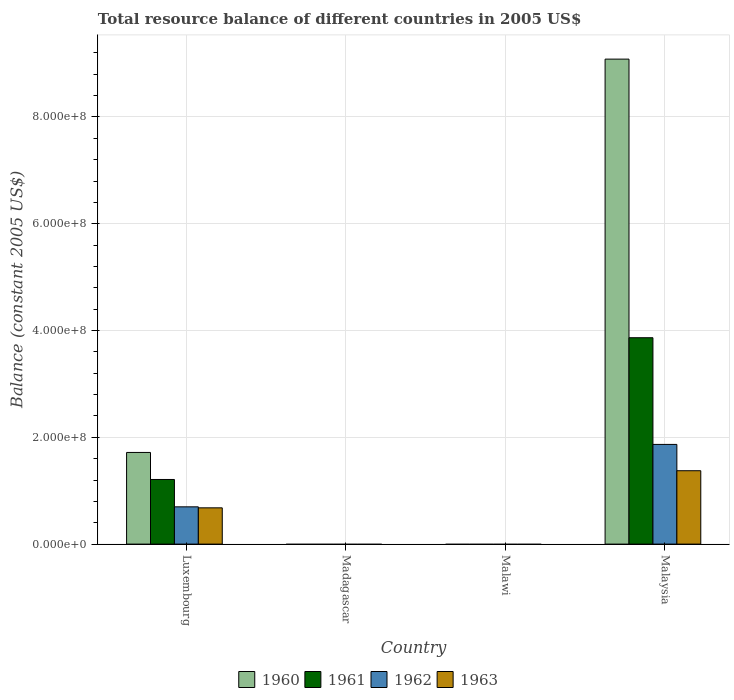Are the number of bars on each tick of the X-axis equal?
Offer a terse response. No. What is the label of the 4th group of bars from the left?
Your response must be concise. Malaysia. In how many cases, is the number of bars for a given country not equal to the number of legend labels?
Your answer should be very brief. 2. Across all countries, what is the maximum total resource balance in 1962?
Keep it short and to the point. 1.87e+08. In which country was the total resource balance in 1961 maximum?
Your answer should be very brief. Malaysia. What is the total total resource balance in 1961 in the graph?
Make the answer very short. 5.08e+08. What is the difference between the total resource balance in 1960 in Luxembourg and that in Malaysia?
Provide a succinct answer. -7.37e+08. What is the difference between the total resource balance in 1962 in Malawi and the total resource balance in 1961 in Malaysia?
Make the answer very short. -3.87e+08. What is the average total resource balance in 1962 per country?
Ensure brevity in your answer.  6.41e+07. What is the difference between the total resource balance of/in 1961 and total resource balance of/in 1962 in Malaysia?
Offer a very short reply. 2.00e+08. In how many countries, is the total resource balance in 1960 greater than 760000000 US$?
Ensure brevity in your answer.  1. What is the ratio of the total resource balance in 1960 in Luxembourg to that in Malaysia?
Give a very brief answer. 0.19. What is the difference between the highest and the lowest total resource balance in 1960?
Your answer should be very brief. 9.08e+08. Is the sum of the total resource balance in 1963 in Luxembourg and Malaysia greater than the maximum total resource balance in 1960 across all countries?
Provide a succinct answer. No. Are all the bars in the graph horizontal?
Offer a terse response. No. How many countries are there in the graph?
Your response must be concise. 4. What is the difference between two consecutive major ticks on the Y-axis?
Offer a very short reply. 2.00e+08. Are the values on the major ticks of Y-axis written in scientific E-notation?
Keep it short and to the point. Yes. Does the graph contain grids?
Your response must be concise. Yes. How many legend labels are there?
Your response must be concise. 4. How are the legend labels stacked?
Offer a very short reply. Horizontal. What is the title of the graph?
Your answer should be compact. Total resource balance of different countries in 2005 US$. What is the label or title of the Y-axis?
Keep it short and to the point. Balance (constant 2005 US$). What is the Balance (constant 2005 US$) of 1960 in Luxembourg?
Your response must be concise. 1.72e+08. What is the Balance (constant 2005 US$) in 1961 in Luxembourg?
Make the answer very short. 1.21e+08. What is the Balance (constant 2005 US$) in 1962 in Luxembourg?
Your answer should be compact. 6.98e+07. What is the Balance (constant 2005 US$) of 1963 in Luxembourg?
Keep it short and to the point. 6.79e+07. What is the Balance (constant 2005 US$) of 1961 in Madagascar?
Offer a terse response. 0. What is the Balance (constant 2005 US$) in 1963 in Madagascar?
Your response must be concise. 0. What is the Balance (constant 2005 US$) in 1962 in Malawi?
Offer a terse response. 0. What is the Balance (constant 2005 US$) of 1960 in Malaysia?
Provide a short and direct response. 9.08e+08. What is the Balance (constant 2005 US$) in 1961 in Malaysia?
Ensure brevity in your answer.  3.87e+08. What is the Balance (constant 2005 US$) of 1962 in Malaysia?
Provide a short and direct response. 1.87e+08. What is the Balance (constant 2005 US$) in 1963 in Malaysia?
Ensure brevity in your answer.  1.37e+08. Across all countries, what is the maximum Balance (constant 2005 US$) of 1960?
Your response must be concise. 9.08e+08. Across all countries, what is the maximum Balance (constant 2005 US$) of 1961?
Provide a succinct answer. 3.87e+08. Across all countries, what is the maximum Balance (constant 2005 US$) of 1962?
Provide a succinct answer. 1.87e+08. Across all countries, what is the maximum Balance (constant 2005 US$) in 1963?
Offer a terse response. 1.37e+08. Across all countries, what is the minimum Balance (constant 2005 US$) in 1960?
Offer a very short reply. 0. Across all countries, what is the minimum Balance (constant 2005 US$) in 1961?
Your response must be concise. 0. Across all countries, what is the minimum Balance (constant 2005 US$) of 1963?
Ensure brevity in your answer.  0. What is the total Balance (constant 2005 US$) of 1960 in the graph?
Your answer should be very brief. 1.08e+09. What is the total Balance (constant 2005 US$) in 1961 in the graph?
Offer a very short reply. 5.08e+08. What is the total Balance (constant 2005 US$) of 1962 in the graph?
Your answer should be very brief. 2.56e+08. What is the total Balance (constant 2005 US$) in 1963 in the graph?
Offer a very short reply. 2.05e+08. What is the difference between the Balance (constant 2005 US$) in 1960 in Luxembourg and that in Malaysia?
Offer a terse response. -7.37e+08. What is the difference between the Balance (constant 2005 US$) of 1961 in Luxembourg and that in Malaysia?
Offer a very short reply. -2.65e+08. What is the difference between the Balance (constant 2005 US$) in 1962 in Luxembourg and that in Malaysia?
Make the answer very short. -1.17e+08. What is the difference between the Balance (constant 2005 US$) in 1963 in Luxembourg and that in Malaysia?
Make the answer very short. -6.95e+07. What is the difference between the Balance (constant 2005 US$) of 1960 in Luxembourg and the Balance (constant 2005 US$) of 1961 in Malaysia?
Your answer should be compact. -2.15e+08. What is the difference between the Balance (constant 2005 US$) of 1960 in Luxembourg and the Balance (constant 2005 US$) of 1962 in Malaysia?
Offer a terse response. -1.50e+07. What is the difference between the Balance (constant 2005 US$) of 1960 in Luxembourg and the Balance (constant 2005 US$) of 1963 in Malaysia?
Offer a very short reply. 3.42e+07. What is the difference between the Balance (constant 2005 US$) of 1961 in Luxembourg and the Balance (constant 2005 US$) of 1962 in Malaysia?
Give a very brief answer. -6.57e+07. What is the difference between the Balance (constant 2005 US$) in 1961 in Luxembourg and the Balance (constant 2005 US$) in 1963 in Malaysia?
Ensure brevity in your answer.  -1.64e+07. What is the difference between the Balance (constant 2005 US$) of 1962 in Luxembourg and the Balance (constant 2005 US$) of 1963 in Malaysia?
Provide a short and direct response. -6.76e+07. What is the average Balance (constant 2005 US$) in 1960 per country?
Your response must be concise. 2.70e+08. What is the average Balance (constant 2005 US$) of 1961 per country?
Offer a very short reply. 1.27e+08. What is the average Balance (constant 2005 US$) of 1962 per country?
Give a very brief answer. 6.41e+07. What is the average Balance (constant 2005 US$) in 1963 per country?
Offer a terse response. 5.13e+07. What is the difference between the Balance (constant 2005 US$) of 1960 and Balance (constant 2005 US$) of 1961 in Luxembourg?
Your answer should be very brief. 5.06e+07. What is the difference between the Balance (constant 2005 US$) of 1960 and Balance (constant 2005 US$) of 1962 in Luxembourg?
Ensure brevity in your answer.  1.02e+08. What is the difference between the Balance (constant 2005 US$) of 1960 and Balance (constant 2005 US$) of 1963 in Luxembourg?
Provide a short and direct response. 1.04e+08. What is the difference between the Balance (constant 2005 US$) of 1961 and Balance (constant 2005 US$) of 1962 in Luxembourg?
Provide a short and direct response. 5.12e+07. What is the difference between the Balance (constant 2005 US$) of 1961 and Balance (constant 2005 US$) of 1963 in Luxembourg?
Your answer should be very brief. 5.31e+07. What is the difference between the Balance (constant 2005 US$) of 1962 and Balance (constant 2005 US$) of 1963 in Luxembourg?
Keep it short and to the point. 1.88e+06. What is the difference between the Balance (constant 2005 US$) in 1960 and Balance (constant 2005 US$) in 1961 in Malaysia?
Ensure brevity in your answer.  5.22e+08. What is the difference between the Balance (constant 2005 US$) in 1960 and Balance (constant 2005 US$) in 1962 in Malaysia?
Offer a very short reply. 7.22e+08. What is the difference between the Balance (constant 2005 US$) in 1960 and Balance (constant 2005 US$) in 1963 in Malaysia?
Your response must be concise. 7.71e+08. What is the difference between the Balance (constant 2005 US$) of 1961 and Balance (constant 2005 US$) of 1962 in Malaysia?
Provide a succinct answer. 2.00e+08. What is the difference between the Balance (constant 2005 US$) in 1961 and Balance (constant 2005 US$) in 1963 in Malaysia?
Give a very brief answer. 2.49e+08. What is the difference between the Balance (constant 2005 US$) of 1962 and Balance (constant 2005 US$) of 1963 in Malaysia?
Ensure brevity in your answer.  4.93e+07. What is the ratio of the Balance (constant 2005 US$) of 1960 in Luxembourg to that in Malaysia?
Provide a short and direct response. 0.19. What is the ratio of the Balance (constant 2005 US$) in 1961 in Luxembourg to that in Malaysia?
Provide a short and direct response. 0.31. What is the ratio of the Balance (constant 2005 US$) of 1962 in Luxembourg to that in Malaysia?
Give a very brief answer. 0.37. What is the ratio of the Balance (constant 2005 US$) in 1963 in Luxembourg to that in Malaysia?
Provide a succinct answer. 0.49. What is the difference between the highest and the lowest Balance (constant 2005 US$) in 1960?
Offer a very short reply. 9.08e+08. What is the difference between the highest and the lowest Balance (constant 2005 US$) in 1961?
Your answer should be very brief. 3.87e+08. What is the difference between the highest and the lowest Balance (constant 2005 US$) of 1962?
Ensure brevity in your answer.  1.87e+08. What is the difference between the highest and the lowest Balance (constant 2005 US$) of 1963?
Offer a very short reply. 1.37e+08. 